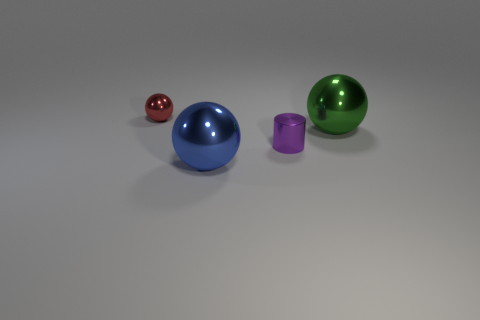How big is the sphere that is to the right of the small metallic object that is right of the small red shiny sphere?
Provide a short and direct response. Large. There is a green thing that is the same shape as the red thing; what is its material?
Provide a short and direct response. Metal. How many big blue spheres are there?
Make the answer very short. 1. There is a small metal thing to the right of the tiny thing to the left of the thing in front of the purple metallic thing; what color is it?
Your answer should be compact. Purple. Are there fewer green things than tiny brown metallic cylinders?
Your answer should be very brief. No. The tiny metallic object that is the same shape as the large blue metallic object is what color?
Keep it short and to the point. Red. What color is the other tiny object that is the same material as the tiny purple object?
Your answer should be compact. Red. How many purple metal cylinders have the same size as the red shiny ball?
Make the answer very short. 1. What is the tiny cylinder made of?
Make the answer very short. Metal. Are there more big green cylinders than big green spheres?
Offer a very short reply. No. 